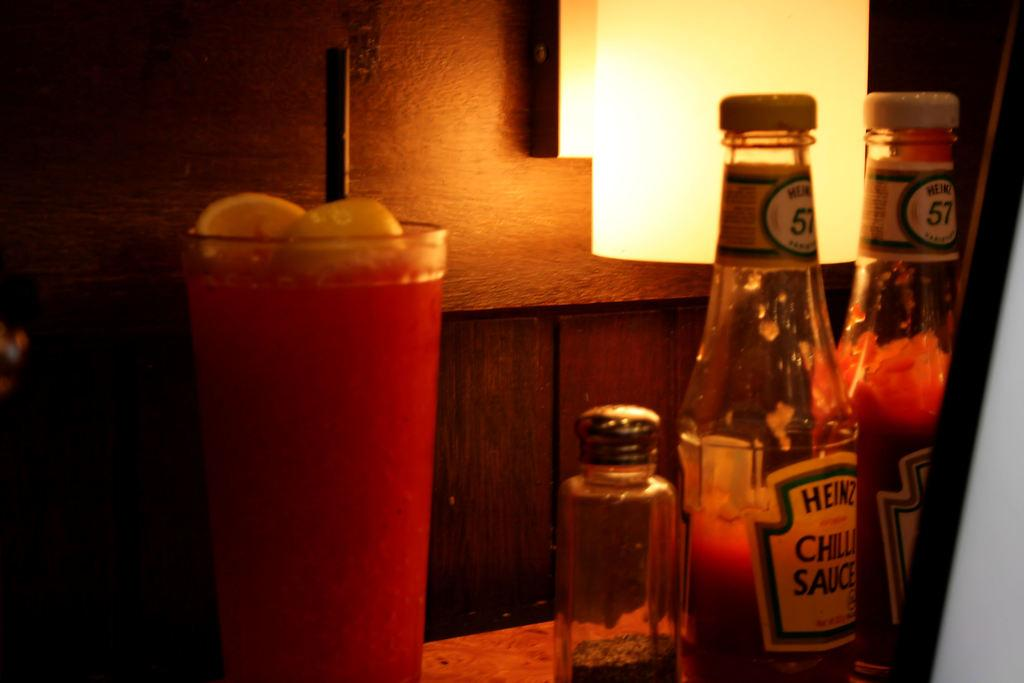<image>
Offer a succinct explanation of the picture presented. Heinz Chili Sauce with pepper and a cup that is filled. 